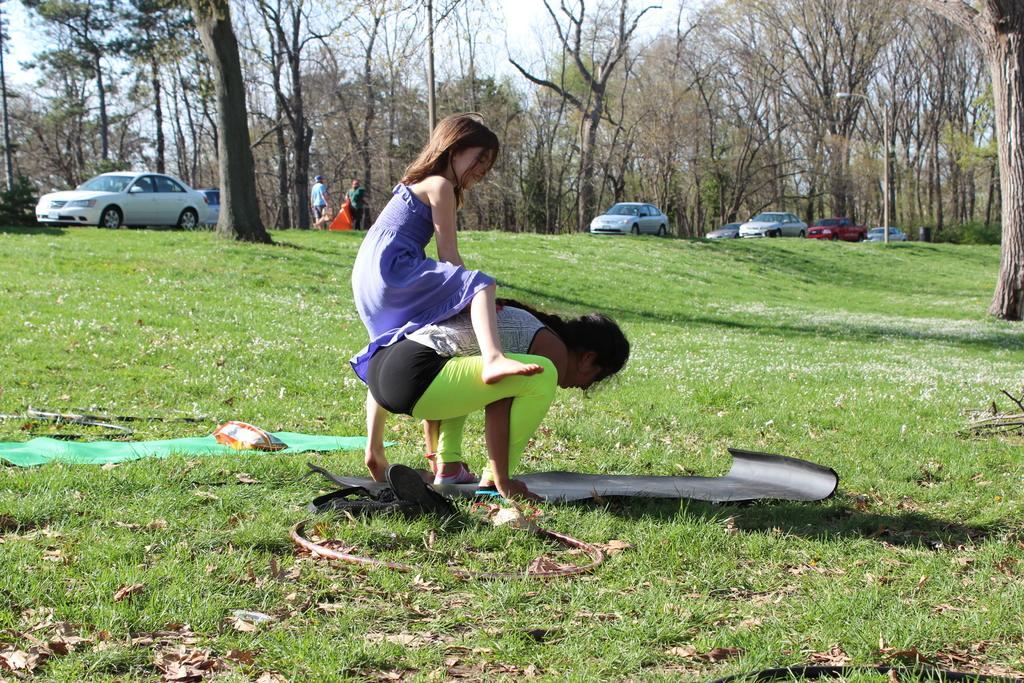Describe this image in one or two sentences. In this image in the front of there are dry leaves on the ground and in the center there are persons standing and in the background there are cars, trees and there are persons walking. In the centro on the ground there are objects which are green and black in colour. 